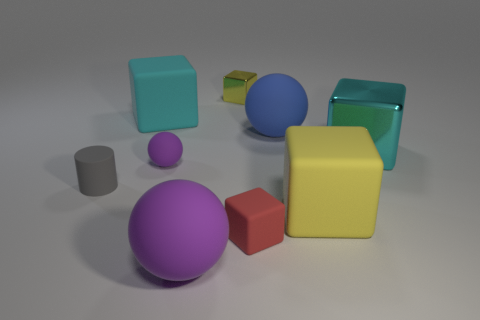There is a big cyan matte object; is its shape the same as the metallic object that is in front of the yellow metal thing?
Offer a terse response. Yes. What shape is the big thing that is the same color as the tiny metal block?
Provide a succinct answer. Cube. Are there any other big objects made of the same material as the blue object?
Your response must be concise. Yes. What material is the small block in front of the yellow block that is in front of the cyan metallic object?
Your answer should be very brief. Rubber. There is a cyan object in front of the large rubber sphere that is behind the big matte ball to the left of the small metallic object; what is its size?
Your answer should be compact. Large. How many other things are there of the same shape as the red object?
Give a very brief answer. 4. There is a metal block that is left of the blue ball; is its color the same as the large block in front of the tiny rubber sphere?
Keep it short and to the point. Yes. There is a matte sphere that is the same size as the cylinder; what is its color?
Make the answer very short. Purple. Is there a object that has the same color as the small metallic block?
Your answer should be very brief. Yes. There is a purple rubber sphere behind the gray object; is it the same size as the tiny matte cylinder?
Make the answer very short. Yes. 